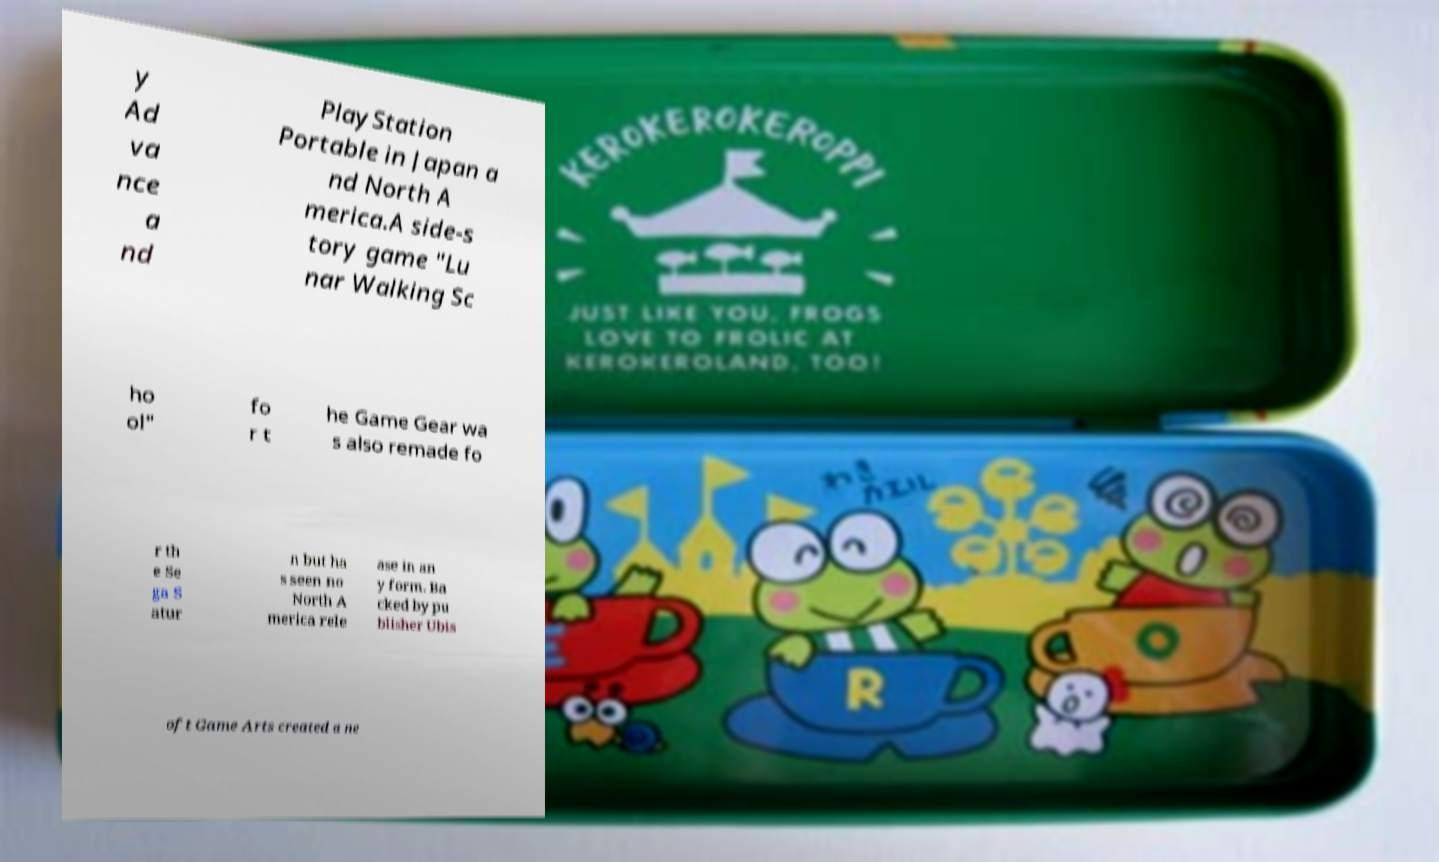There's text embedded in this image that I need extracted. Can you transcribe it verbatim? y Ad va nce a nd PlayStation Portable in Japan a nd North A merica.A side-s tory game "Lu nar Walking Sc ho ol" fo r t he Game Gear wa s also remade fo r th e Se ga S atur n but ha s seen no North A merica rele ase in an y form. Ba cked by pu blisher Ubis oft Game Arts created a ne 